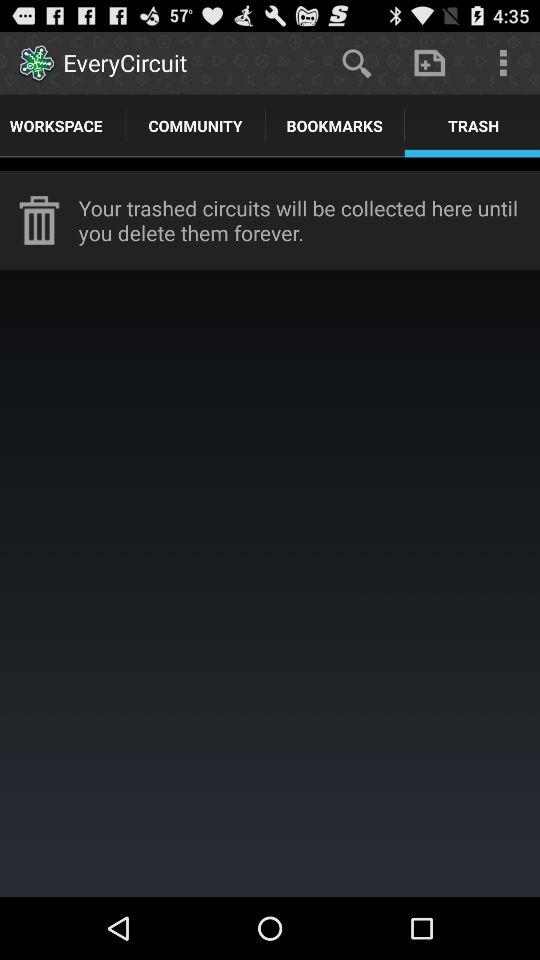Which tab has been selected? The selected tab is "TRASH". 